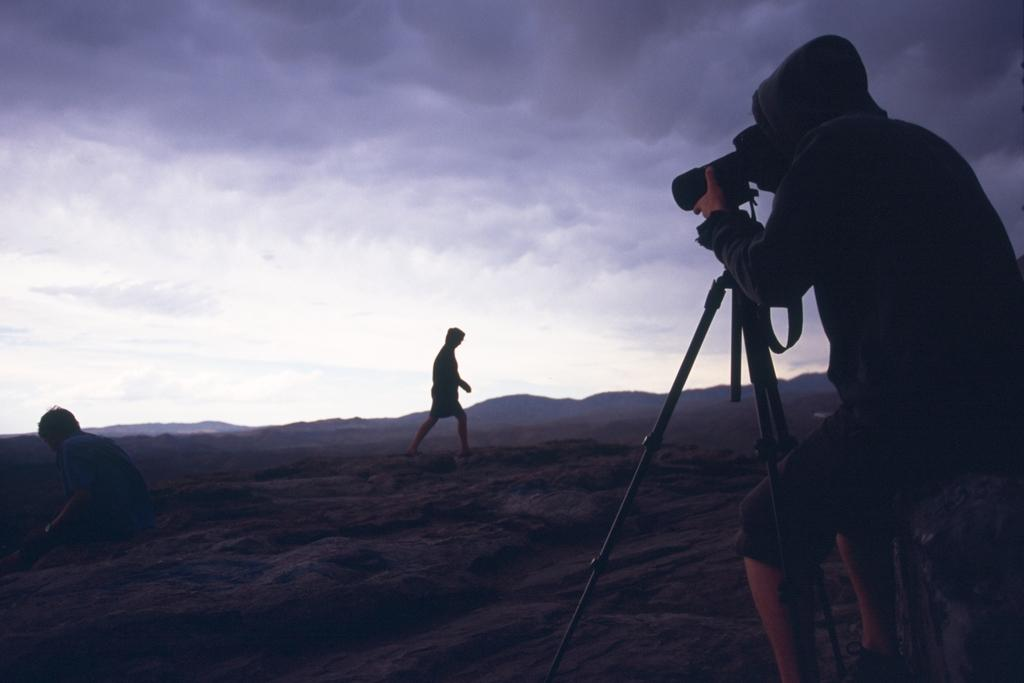What is the main subject of the image? There is a person standing in the image. What equipment is visible in the image? There is a camera stand and a camera in the image. What is the other person in the image doing? There is a person walking in the image. What can be seen in the background of the image? The sky is visible at the top of the image. Where is the nest located in the image? There is no nest present in the image. Who is the manager of the person walking in the image? There is no mention of a manager in the image. How many cats can be seen in the image? There are no cats present in the image. 